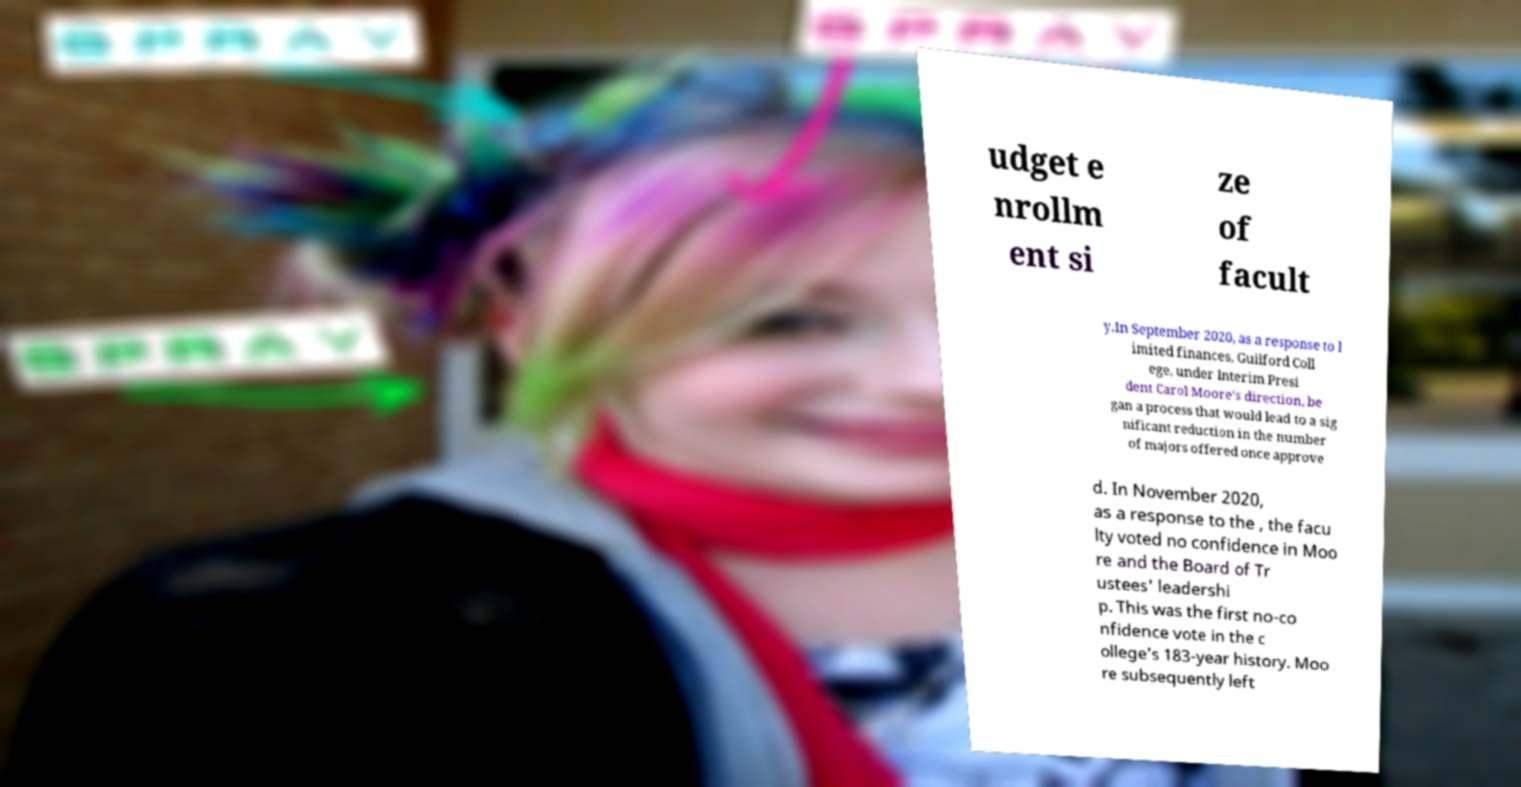Could you assist in decoding the text presented in this image and type it out clearly? udget e nrollm ent si ze of facult y.In September 2020, as a response to l imited finances, Guilford Coll ege, under Interim Presi dent Carol Moore’s direction, be gan a process that would lead to a sig nificant reduction in the number of majors offered once approve d. In November 2020, as a response to the , the facu lty voted no confidence in Moo re and the Board of Tr ustees' leadershi p. This was the first no-co nfidence vote in the c ollege’s 183-year history. Moo re subsequently left 